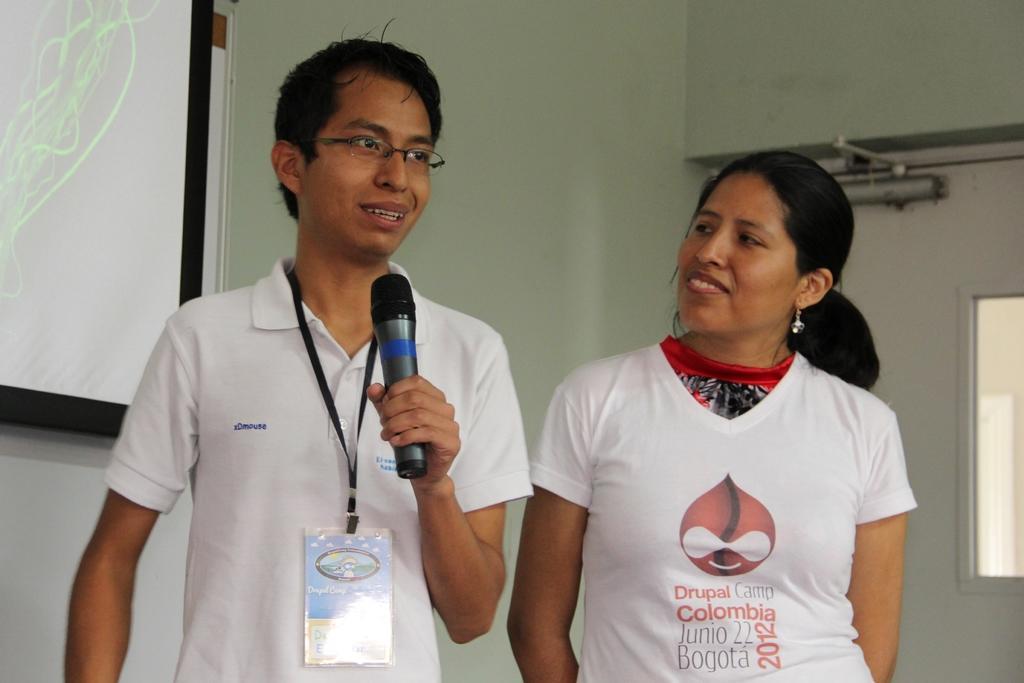How would you summarize this image in a sentence or two? In this image we can see a man and a woman standing. In that a man is holding a mic. On the backside we can see the projector, a wall and a window. 